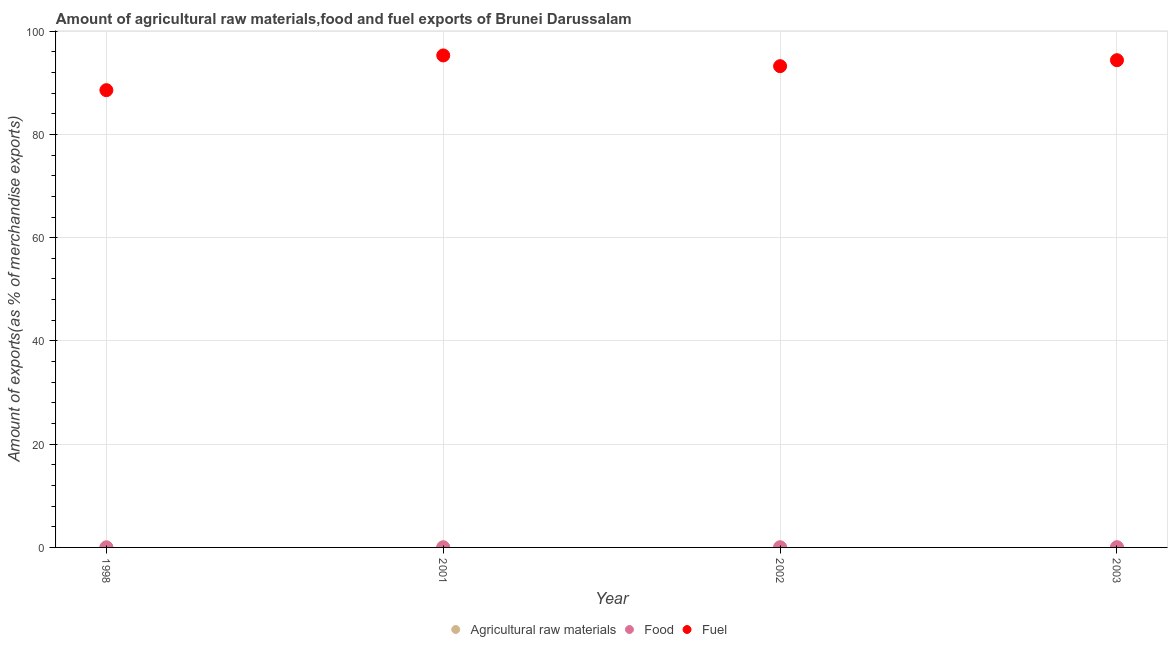What is the percentage of fuel exports in 1998?
Give a very brief answer. 88.58. Across all years, what is the maximum percentage of fuel exports?
Keep it short and to the point. 95.31. Across all years, what is the minimum percentage of fuel exports?
Provide a short and direct response. 88.58. In which year was the percentage of raw materials exports minimum?
Offer a very short reply. 1998. What is the total percentage of raw materials exports in the graph?
Provide a succinct answer. 0.02. What is the difference between the percentage of food exports in 1998 and that in 2003?
Your answer should be compact. -0.03. What is the difference between the percentage of fuel exports in 2001 and the percentage of food exports in 1998?
Offer a terse response. 95.3. What is the average percentage of fuel exports per year?
Offer a very short reply. 92.87. In the year 2003, what is the difference between the percentage of fuel exports and percentage of raw materials exports?
Provide a short and direct response. 94.38. What is the ratio of the percentage of raw materials exports in 1998 to that in 2001?
Offer a terse response. 0.61. Is the percentage of fuel exports in 2002 less than that in 2003?
Your response must be concise. Yes. Is the difference between the percentage of food exports in 2001 and 2002 greater than the difference between the percentage of raw materials exports in 2001 and 2002?
Give a very brief answer. Yes. What is the difference between the highest and the second highest percentage of raw materials exports?
Provide a short and direct response. 0. What is the difference between the highest and the lowest percentage of raw materials exports?
Keep it short and to the point. 0. Is it the case that in every year, the sum of the percentage of raw materials exports and percentage of food exports is greater than the percentage of fuel exports?
Offer a very short reply. No. Does the percentage of fuel exports monotonically increase over the years?
Offer a terse response. No. Is the percentage of fuel exports strictly greater than the percentage of food exports over the years?
Provide a short and direct response. Yes. Is the percentage of food exports strictly less than the percentage of raw materials exports over the years?
Provide a short and direct response. No. How many years are there in the graph?
Keep it short and to the point. 4. What is the difference between two consecutive major ticks on the Y-axis?
Your answer should be compact. 20. Are the values on the major ticks of Y-axis written in scientific E-notation?
Ensure brevity in your answer.  No. Does the graph contain any zero values?
Your response must be concise. No. How many legend labels are there?
Provide a short and direct response. 3. What is the title of the graph?
Offer a very short reply. Amount of agricultural raw materials,food and fuel exports of Brunei Darussalam. What is the label or title of the X-axis?
Offer a very short reply. Year. What is the label or title of the Y-axis?
Ensure brevity in your answer.  Amount of exports(as % of merchandise exports). What is the Amount of exports(as % of merchandise exports) of Agricultural raw materials in 1998?
Ensure brevity in your answer.  0. What is the Amount of exports(as % of merchandise exports) in Food in 1998?
Offer a terse response. 0.01. What is the Amount of exports(as % of merchandise exports) of Fuel in 1998?
Provide a succinct answer. 88.58. What is the Amount of exports(as % of merchandise exports) in Agricultural raw materials in 2001?
Give a very brief answer. 0. What is the Amount of exports(as % of merchandise exports) in Food in 2001?
Your answer should be compact. 0.02. What is the Amount of exports(as % of merchandise exports) of Fuel in 2001?
Your answer should be very brief. 95.31. What is the Amount of exports(as % of merchandise exports) of Agricultural raw materials in 2002?
Provide a succinct answer. 0.01. What is the Amount of exports(as % of merchandise exports) in Food in 2002?
Make the answer very short. 0.02. What is the Amount of exports(as % of merchandise exports) in Fuel in 2002?
Provide a short and direct response. 93.23. What is the Amount of exports(as % of merchandise exports) in Agricultural raw materials in 2003?
Offer a very short reply. 0. What is the Amount of exports(as % of merchandise exports) in Food in 2003?
Offer a very short reply. 0.04. What is the Amount of exports(as % of merchandise exports) in Fuel in 2003?
Keep it short and to the point. 94.38. Across all years, what is the maximum Amount of exports(as % of merchandise exports) in Agricultural raw materials?
Make the answer very short. 0.01. Across all years, what is the maximum Amount of exports(as % of merchandise exports) of Food?
Your answer should be very brief. 0.04. Across all years, what is the maximum Amount of exports(as % of merchandise exports) in Fuel?
Your answer should be very brief. 95.31. Across all years, what is the minimum Amount of exports(as % of merchandise exports) of Agricultural raw materials?
Make the answer very short. 0. Across all years, what is the minimum Amount of exports(as % of merchandise exports) of Food?
Your response must be concise. 0.01. Across all years, what is the minimum Amount of exports(as % of merchandise exports) in Fuel?
Offer a very short reply. 88.58. What is the total Amount of exports(as % of merchandise exports) of Agricultural raw materials in the graph?
Offer a terse response. 0.02. What is the total Amount of exports(as % of merchandise exports) of Food in the graph?
Offer a very short reply. 0.09. What is the total Amount of exports(as % of merchandise exports) in Fuel in the graph?
Offer a very short reply. 371.49. What is the difference between the Amount of exports(as % of merchandise exports) in Agricultural raw materials in 1998 and that in 2001?
Keep it short and to the point. -0. What is the difference between the Amount of exports(as % of merchandise exports) in Food in 1998 and that in 2001?
Your answer should be compact. -0.01. What is the difference between the Amount of exports(as % of merchandise exports) in Fuel in 1998 and that in 2001?
Provide a succinct answer. -6.73. What is the difference between the Amount of exports(as % of merchandise exports) in Agricultural raw materials in 1998 and that in 2002?
Your answer should be very brief. -0. What is the difference between the Amount of exports(as % of merchandise exports) of Food in 1998 and that in 2002?
Provide a short and direct response. -0.01. What is the difference between the Amount of exports(as % of merchandise exports) of Fuel in 1998 and that in 2002?
Offer a very short reply. -4.65. What is the difference between the Amount of exports(as % of merchandise exports) in Agricultural raw materials in 1998 and that in 2003?
Make the answer very short. -0. What is the difference between the Amount of exports(as % of merchandise exports) in Food in 1998 and that in 2003?
Ensure brevity in your answer.  -0.03. What is the difference between the Amount of exports(as % of merchandise exports) in Fuel in 1998 and that in 2003?
Offer a terse response. -5.8. What is the difference between the Amount of exports(as % of merchandise exports) in Agricultural raw materials in 2001 and that in 2002?
Offer a very short reply. -0. What is the difference between the Amount of exports(as % of merchandise exports) of Food in 2001 and that in 2002?
Make the answer very short. 0. What is the difference between the Amount of exports(as % of merchandise exports) in Fuel in 2001 and that in 2002?
Make the answer very short. 2.08. What is the difference between the Amount of exports(as % of merchandise exports) of Agricultural raw materials in 2001 and that in 2003?
Provide a succinct answer. -0. What is the difference between the Amount of exports(as % of merchandise exports) of Food in 2001 and that in 2003?
Keep it short and to the point. -0.02. What is the difference between the Amount of exports(as % of merchandise exports) in Fuel in 2001 and that in 2003?
Keep it short and to the point. 0.92. What is the difference between the Amount of exports(as % of merchandise exports) in Food in 2002 and that in 2003?
Provide a succinct answer. -0.02. What is the difference between the Amount of exports(as % of merchandise exports) of Fuel in 2002 and that in 2003?
Keep it short and to the point. -1.16. What is the difference between the Amount of exports(as % of merchandise exports) in Agricultural raw materials in 1998 and the Amount of exports(as % of merchandise exports) in Food in 2001?
Your answer should be compact. -0.02. What is the difference between the Amount of exports(as % of merchandise exports) in Agricultural raw materials in 1998 and the Amount of exports(as % of merchandise exports) in Fuel in 2001?
Give a very brief answer. -95.3. What is the difference between the Amount of exports(as % of merchandise exports) of Food in 1998 and the Amount of exports(as % of merchandise exports) of Fuel in 2001?
Give a very brief answer. -95.3. What is the difference between the Amount of exports(as % of merchandise exports) of Agricultural raw materials in 1998 and the Amount of exports(as % of merchandise exports) of Food in 2002?
Provide a short and direct response. -0.02. What is the difference between the Amount of exports(as % of merchandise exports) in Agricultural raw materials in 1998 and the Amount of exports(as % of merchandise exports) in Fuel in 2002?
Your answer should be very brief. -93.22. What is the difference between the Amount of exports(as % of merchandise exports) in Food in 1998 and the Amount of exports(as % of merchandise exports) in Fuel in 2002?
Make the answer very short. -93.22. What is the difference between the Amount of exports(as % of merchandise exports) in Agricultural raw materials in 1998 and the Amount of exports(as % of merchandise exports) in Food in 2003?
Make the answer very short. -0.04. What is the difference between the Amount of exports(as % of merchandise exports) of Agricultural raw materials in 1998 and the Amount of exports(as % of merchandise exports) of Fuel in 2003?
Offer a very short reply. -94.38. What is the difference between the Amount of exports(as % of merchandise exports) in Food in 1998 and the Amount of exports(as % of merchandise exports) in Fuel in 2003?
Ensure brevity in your answer.  -94.37. What is the difference between the Amount of exports(as % of merchandise exports) of Agricultural raw materials in 2001 and the Amount of exports(as % of merchandise exports) of Food in 2002?
Ensure brevity in your answer.  -0.02. What is the difference between the Amount of exports(as % of merchandise exports) in Agricultural raw materials in 2001 and the Amount of exports(as % of merchandise exports) in Fuel in 2002?
Offer a terse response. -93.22. What is the difference between the Amount of exports(as % of merchandise exports) of Food in 2001 and the Amount of exports(as % of merchandise exports) of Fuel in 2002?
Make the answer very short. -93.21. What is the difference between the Amount of exports(as % of merchandise exports) in Agricultural raw materials in 2001 and the Amount of exports(as % of merchandise exports) in Food in 2003?
Ensure brevity in your answer.  -0.04. What is the difference between the Amount of exports(as % of merchandise exports) in Agricultural raw materials in 2001 and the Amount of exports(as % of merchandise exports) in Fuel in 2003?
Ensure brevity in your answer.  -94.38. What is the difference between the Amount of exports(as % of merchandise exports) in Food in 2001 and the Amount of exports(as % of merchandise exports) in Fuel in 2003?
Offer a terse response. -94.36. What is the difference between the Amount of exports(as % of merchandise exports) of Agricultural raw materials in 2002 and the Amount of exports(as % of merchandise exports) of Food in 2003?
Make the answer very short. -0.03. What is the difference between the Amount of exports(as % of merchandise exports) in Agricultural raw materials in 2002 and the Amount of exports(as % of merchandise exports) in Fuel in 2003?
Your response must be concise. -94.38. What is the difference between the Amount of exports(as % of merchandise exports) in Food in 2002 and the Amount of exports(as % of merchandise exports) in Fuel in 2003?
Offer a terse response. -94.36. What is the average Amount of exports(as % of merchandise exports) in Agricultural raw materials per year?
Your response must be concise. 0. What is the average Amount of exports(as % of merchandise exports) of Food per year?
Make the answer very short. 0.02. What is the average Amount of exports(as % of merchandise exports) of Fuel per year?
Provide a succinct answer. 92.87. In the year 1998, what is the difference between the Amount of exports(as % of merchandise exports) of Agricultural raw materials and Amount of exports(as % of merchandise exports) of Food?
Provide a short and direct response. -0.01. In the year 1998, what is the difference between the Amount of exports(as % of merchandise exports) in Agricultural raw materials and Amount of exports(as % of merchandise exports) in Fuel?
Provide a succinct answer. -88.57. In the year 1998, what is the difference between the Amount of exports(as % of merchandise exports) of Food and Amount of exports(as % of merchandise exports) of Fuel?
Keep it short and to the point. -88.57. In the year 2001, what is the difference between the Amount of exports(as % of merchandise exports) in Agricultural raw materials and Amount of exports(as % of merchandise exports) in Food?
Your answer should be very brief. -0.02. In the year 2001, what is the difference between the Amount of exports(as % of merchandise exports) of Agricultural raw materials and Amount of exports(as % of merchandise exports) of Fuel?
Your answer should be very brief. -95.3. In the year 2001, what is the difference between the Amount of exports(as % of merchandise exports) in Food and Amount of exports(as % of merchandise exports) in Fuel?
Your answer should be very brief. -95.29. In the year 2002, what is the difference between the Amount of exports(as % of merchandise exports) in Agricultural raw materials and Amount of exports(as % of merchandise exports) in Food?
Your answer should be compact. -0.01. In the year 2002, what is the difference between the Amount of exports(as % of merchandise exports) of Agricultural raw materials and Amount of exports(as % of merchandise exports) of Fuel?
Provide a succinct answer. -93.22. In the year 2002, what is the difference between the Amount of exports(as % of merchandise exports) of Food and Amount of exports(as % of merchandise exports) of Fuel?
Provide a succinct answer. -93.21. In the year 2003, what is the difference between the Amount of exports(as % of merchandise exports) in Agricultural raw materials and Amount of exports(as % of merchandise exports) in Food?
Provide a succinct answer. -0.03. In the year 2003, what is the difference between the Amount of exports(as % of merchandise exports) of Agricultural raw materials and Amount of exports(as % of merchandise exports) of Fuel?
Provide a succinct answer. -94.38. In the year 2003, what is the difference between the Amount of exports(as % of merchandise exports) in Food and Amount of exports(as % of merchandise exports) in Fuel?
Give a very brief answer. -94.34. What is the ratio of the Amount of exports(as % of merchandise exports) in Agricultural raw materials in 1998 to that in 2001?
Provide a succinct answer. 0.61. What is the ratio of the Amount of exports(as % of merchandise exports) in Food in 1998 to that in 2001?
Keep it short and to the point. 0.51. What is the ratio of the Amount of exports(as % of merchandise exports) of Fuel in 1998 to that in 2001?
Your response must be concise. 0.93. What is the ratio of the Amount of exports(as % of merchandise exports) of Agricultural raw materials in 1998 to that in 2002?
Keep it short and to the point. 0.48. What is the ratio of the Amount of exports(as % of merchandise exports) in Food in 1998 to that in 2002?
Your answer should be very brief. 0.51. What is the ratio of the Amount of exports(as % of merchandise exports) in Fuel in 1998 to that in 2002?
Your answer should be very brief. 0.95. What is the ratio of the Amount of exports(as % of merchandise exports) in Agricultural raw materials in 1998 to that in 2003?
Give a very brief answer. 0.52. What is the ratio of the Amount of exports(as % of merchandise exports) of Food in 1998 to that in 2003?
Offer a terse response. 0.26. What is the ratio of the Amount of exports(as % of merchandise exports) of Fuel in 1998 to that in 2003?
Keep it short and to the point. 0.94. What is the ratio of the Amount of exports(as % of merchandise exports) of Agricultural raw materials in 2001 to that in 2002?
Keep it short and to the point. 0.79. What is the ratio of the Amount of exports(as % of merchandise exports) of Food in 2001 to that in 2002?
Keep it short and to the point. 1.01. What is the ratio of the Amount of exports(as % of merchandise exports) of Fuel in 2001 to that in 2002?
Keep it short and to the point. 1.02. What is the ratio of the Amount of exports(as % of merchandise exports) of Agricultural raw materials in 2001 to that in 2003?
Your answer should be very brief. 0.85. What is the ratio of the Amount of exports(as % of merchandise exports) in Food in 2001 to that in 2003?
Your response must be concise. 0.52. What is the ratio of the Amount of exports(as % of merchandise exports) in Fuel in 2001 to that in 2003?
Provide a short and direct response. 1.01. What is the ratio of the Amount of exports(as % of merchandise exports) of Agricultural raw materials in 2002 to that in 2003?
Offer a very short reply. 1.08. What is the ratio of the Amount of exports(as % of merchandise exports) in Food in 2002 to that in 2003?
Offer a terse response. 0.51. What is the difference between the highest and the second highest Amount of exports(as % of merchandise exports) in Food?
Offer a terse response. 0.02. What is the difference between the highest and the second highest Amount of exports(as % of merchandise exports) of Fuel?
Give a very brief answer. 0.92. What is the difference between the highest and the lowest Amount of exports(as % of merchandise exports) of Agricultural raw materials?
Your answer should be very brief. 0. What is the difference between the highest and the lowest Amount of exports(as % of merchandise exports) in Food?
Give a very brief answer. 0.03. What is the difference between the highest and the lowest Amount of exports(as % of merchandise exports) of Fuel?
Offer a terse response. 6.73. 